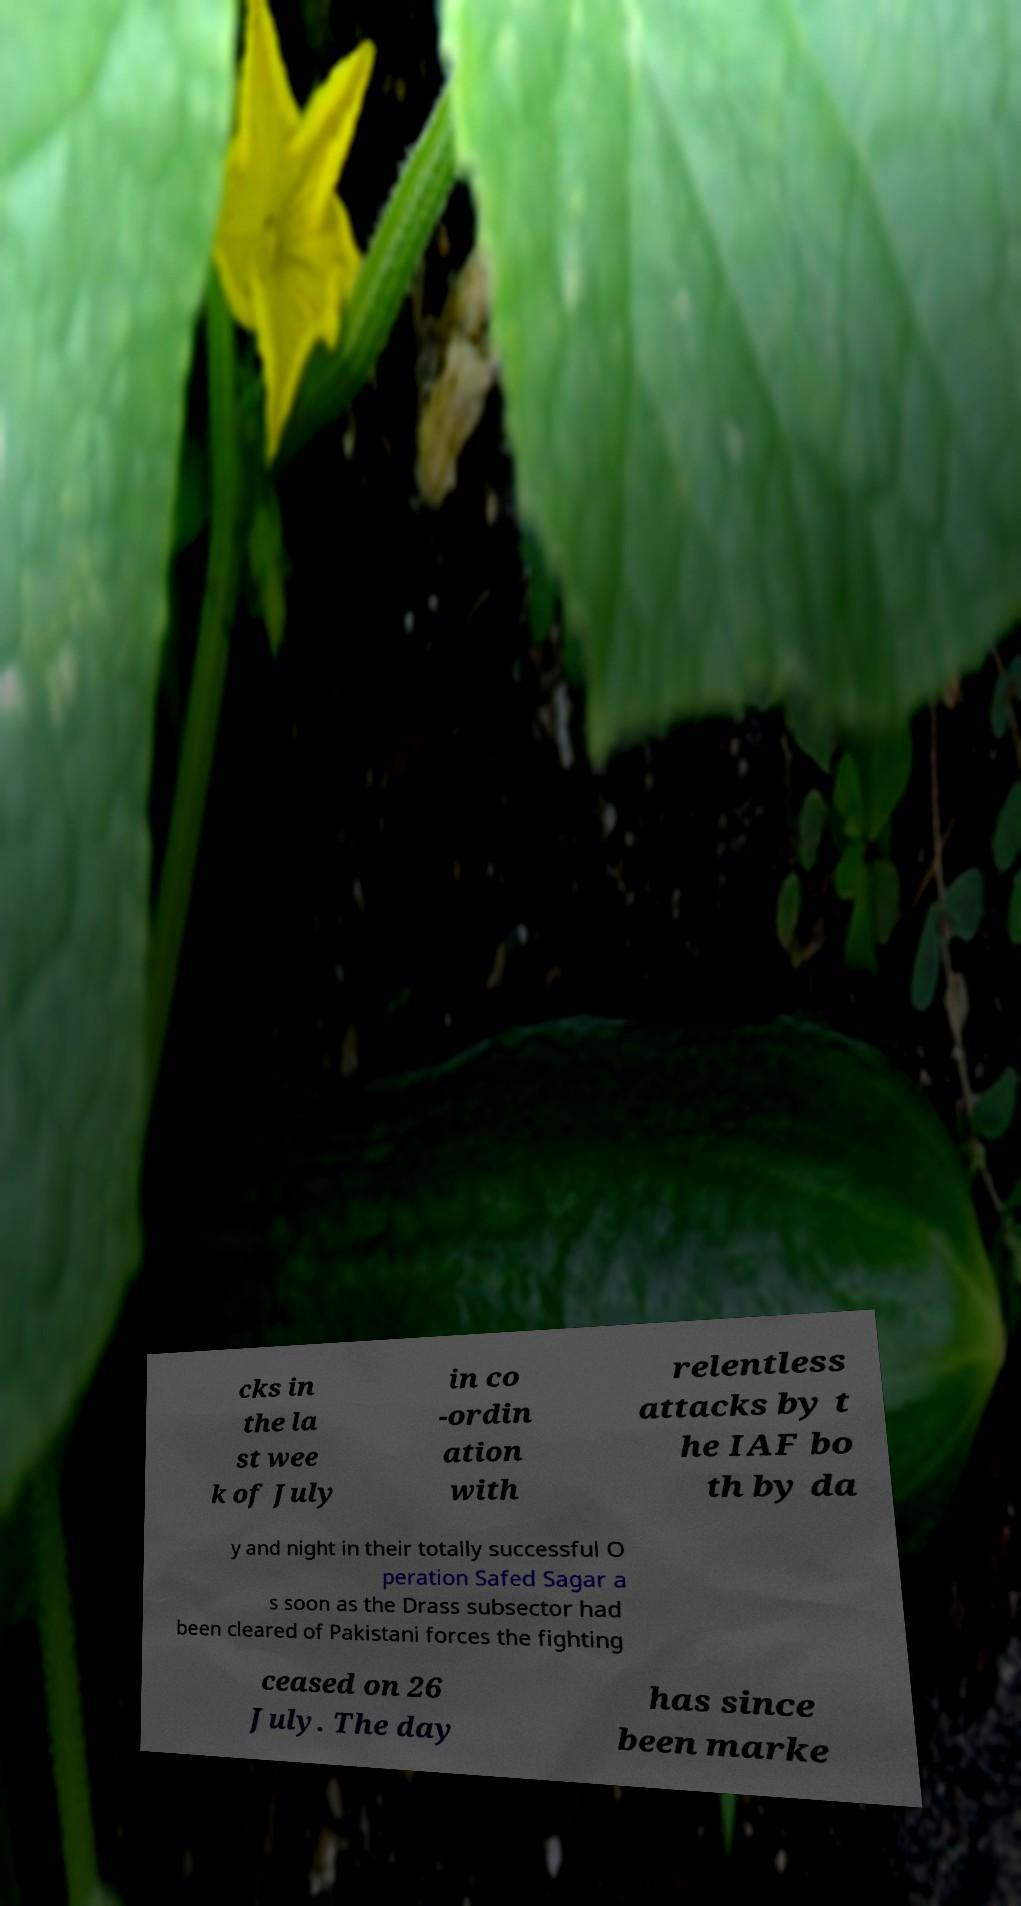Please read and relay the text visible in this image. What does it say? cks in the la st wee k of July in co -ordin ation with relentless attacks by t he IAF bo th by da y and night in their totally successful O peration Safed Sagar a s soon as the Drass subsector had been cleared of Pakistani forces the fighting ceased on 26 July. The day has since been marke 